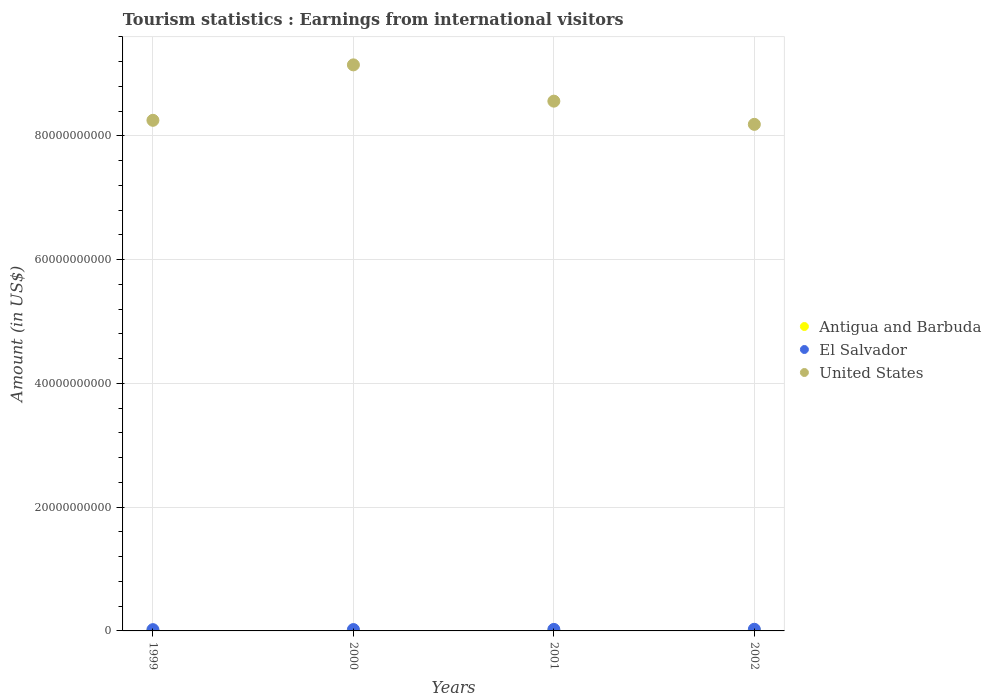What is the earnings from international visitors in Antigua and Barbuda in 2000?
Offer a terse response. 3.10e+07. Across all years, what is the maximum earnings from international visitors in Antigua and Barbuda?
Keep it short and to the point. 3.30e+07. Across all years, what is the minimum earnings from international visitors in United States?
Make the answer very short. 8.19e+1. In which year was the earnings from international visitors in El Salvador maximum?
Keep it short and to the point. 2002. What is the total earnings from international visitors in El Salvador in the graph?
Ensure brevity in your answer.  9.37e+08. What is the difference between the earnings from international visitors in El Salvador in 2000 and that in 2001?
Ensure brevity in your answer.  -2.80e+07. What is the difference between the earnings from international visitors in United States in 1999 and the earnings from international visitors in Antigua and Barbuda in 2001?
Your answer should be very brief. 8.25e+1. What is the average earnings from international visitors in Antigua and Barbuda per year?
Keep it short and to the point. 3.15e+07. In the year 1999, what is the difference between the earnings from international visitors in United States and earnings from international visitors in Antigua and Barbuda?
Your answer should be compact. 8.25e+1. What is the ratio of the earnings from international visitors in Antigua and Barbuda in 2000 to that in 2002?
Offer a very short reply. 0.94. Is the earnings from international visitors in Antigua and Barbuda in 2000 less than that in 2002?
Ensure brevity in your answer.  Yes. Is the difference between the earnings from international visitors in United States in 2000 and 2001 greater than the difference between the earnings from international visitors in Antigua and Barbuda in 2000 and 2001?
Make the answer very short. Yes. What is the difference between the highest and the second highest earnings from international visitors in El Salvador?
Your response must be concise. 1.90e+07. What is the difference between the highest and the lowest earnings from international visitors in El Salvador?
Ensure brevity in your answer.  6.10e+07. Is the sum of the earnings from international visitors in El Salvador in 1999 and 2001 greater than the maximum earnings from international visitors in United States across all years?
Make the answer very short. No. Is the earnings from international visitors in Antigua and Barbuda strictly greater than the earnings from international visitors in El Salvador over the years?
Your response must be concise. No. Are the values on the major ticks of Y-axis written in scientific E-notation?
Make the answer very short. No. Does the graph contain any zero values?
Your response must be concise. No. Does the graph contain grids?
Ensure brevity in your answer.  Yes. Where does the legend appear in the graph?
Provide a succinct answer. Center right. How many legend labels are there?
Offer a very short reply. 3. How are the legend labels stacked?
Provide a succinct answer. Vertical. What is the title of the graph?
Give a very brief answer. Tourism statistics : Earnings from international visitors. What is the label or title of the X-axis?
Make the answer very short. Years. What is the Amount (in US$) in Antigua and Barbuda in 1999?
Keep it short and to the point. 3.00e+07. What is the Amount (in US$) of El Salvador in 1999?
Provide a short and direct response. 2.05e+08. What is the Amount (in US$) of United States in 1999?
Provide a succinct answer. 8.25e+1. What is the Amount (in US$) in Antigua and Barbuda in 2000?
Your answer should be very brief. 3.10e+07. What is the Amount (in US$) in El Salvador in 2000?
Keep it short and to the point. 2.19e+08. What is the Amount (in US$) of United States in 2000?
Your response must be concise. 9.15e+1. What is the Amount (in US$) in Antigua and Barbuda in 2001?
Give a very brief answer. 3.20e+07. What is the Amount (in US$) of El Salvador in 2001?
Your answer should be very brief. 2.47e+08. What is the Amount (in US$) of United States in 2001?
Keep it short and to the point. 8.56e+1. What is the Amount (in US$) in Antigua and Barbuda in 2002?
Make the answer very short. 3.30e+07. What is the Amount (in US$) of El Salvador in 2002?
Your response must be concise. 2.66e+08. What is the Amount (in US$) in United States in 2002?
Provide a short and direct response. 8.19e+1. Across all years, what is the maximum Amount (in US$) of Antigua and Barbuda?
Your answer should be compact. 3.30e+07. Across all years, what is the maximum Amount (in US$) in El Salvador?
Provide a short and direct response. 2.66e+08. Across all years, what is the maximum Amount (in US$) in United States?
Your answer should be compact. 9.15e+1. Across all years, what is the minimum Amount (in US$) of Antigua and Barbuda?
Make the answer very short. 3.00e+07. Across all years, what is the minimum Amount (in US$) in El Salvador?
Your answer should be compact. 2.05e+08. Across all years, what is the minimum Amount (in US$) of United States?
Make the answer very short. 8.19e+1. What is the total Amount (in US$) of Antigua and Barbuda in the graph?
Your answer should be very brief. 1.26e+08. What is the total Amount (in US$) in El Salvador in the graph?
Keep it short and to the point. 9.37e+08. What is the total Amount (in US$) of United States in the graph?
Provide a short and direct response. 3.41e+11. What is the difference between the Amount (in US$) of El Salvador in 1999 and that in 2000?
Offer a very short reply. -1.40e+07. What is the difference between the Amount (in US$) of United States in 1999 and that in 2000?
Provide a short and direct response. -8.96e+09. What is the difference between the Amount (in US$) of Antigua and Barbuda in 1999 and that in 2001?
Offer a very short reply. -2.00e+06. What is the difference between the Amount (in US$) in El Salvador in 1999 and that in 2001?
Ensure brevity in your answer.  -4.20e+07. What is the difference between the Amount (in US$) in United States in 1999 and that in 2001?
Offer a very short reply. -3.10e+09. What is the difference between the Amount (in US$) in Antigua and Barbuda in 1999 and that in 2002?
Provide a succinct answer. -3.00e+06. What is the difference between the Amount (in US$) of El Salvador in 1999 and that in 2002?
Offer a terse response. -6.10e+07. What is the difference between the Amount (in US$) in United States in 1999 and that in 2002?
Offer a very short reply. 6.53e+08. What is the difference between the Amount (in US$) of El Salvador in 2000 and that in 2001?
Offer a very short reply. -2.80e+07. What is the difference between the Amount (in US$) of United States in 2000 and that in 2001?
Provide a short and direct response. 5.86e+09. What is the difference between the Amount (in US$) in Antigua and Barbuda in 2000 and that in 2002?
Your response must be concise. -2.00e+06. What is the difference between the Amount (in US$) of El Salvador in 2000 and that in 2002?
Your answer should be very brief. -4.70e+07. What is the difference between the Amount (in US$) in United States in 2000 and that in 2002?
Your answer should be very brief. 9.61e+09. What is the difference between the Amount (in US$) of El Salvador in 2001 and that in 2002?
Keep it short and to the point. -1.90e+07. What is the difference between the Amount (in US$) of United States in 2001 and that in 2002?
Give a very brief answer. 3.75e+09. What is the difference between the Amount (in US$) in Antigua and Barbuda in 1999 and the Amount (in US$) in El Salvador in 2000?
Ensure brevity in your answer.  -1.89e+08. What is the difference between the Amount (in US$) in Antigua and Barbuda in 1999 and the Amount (in US$) in United States in 2000?
Your response must be concise. -9.14e+1. What is the difference between the Amount (in US$) of El Salvador in 1999 and the Amount (in US$) of United States in 2000?
Offer a very short reply. -9.13e+1. What is the difference between the Amount (in US$) in Antigua and Barbuda in 1999 and the Amount (in US$) in El Salvador in 2001?
Your answer should be very brief. -2.17e+08. What is the difference between the Amount (in US$) in Antigua and Barbuda in 1999 and the Amount (in US$) in United States in 2001?
Your response must be concise. -8.56e+1. What is the difference between the Amount (in US$) of El Salvador in 1999 and the Amount (in US$) of United States in 2001?
Offer a very short reply. -8.54e+1. What is the difference between the Amount (in US$) in Antigua and Barbuda in 1999 and the Amount (in US$) in El Salvador in 2002?
Ensure brevity in your answer.  -2.36e+08. What is the difference between the Amount (in US$) of Antigua and Barbuda in 1999 and the Amount (in US$) of United States in 2002?
Provide a short and direct response. -8.18e+1. What is the difference between the Amount (in US$) in El Salvador in 1999 and the Amount (in US$) in United States in 2002?
Make the answer very short. -8.17e+1. What is the difference between the Amount (in US$) of Antigua and Barbuda in 2000 and the Amount (in US$) of El Salvador in 2001?
Give a very brief answer. -2.16e+08. What is the difference between the Amount (in US$) of Antigua and Barbuda in 2000 and the Amount (in US$) of United States in 2001?
Provide a succinct answer. -8.56e+1. What is the difference between the Amount (in US$) of El Salvador in 2000 and the Amount (in US$) of United States in 2001?
Your answer should be very brief. -8.54e+1. What is the difference between the Amount (in US$) of Antigua and Barbuda in 2000 and the Amount (in US$) of El Salvador in 2002?
Give a very brief answer. -2.35e+08. What is the difference between the Amount (in US$) of Antigua and Barbuda in 2000 and the Amount (in US$) of United States in 2002?
Give a very brief answer. -8.18e+1. What is the difference between the Amount (in US$) in El Salvador in 2000 and the Amount (in US$) in United States in 2002?
Keep it short and to the point. -8.16e+1. What is the difference between the Amount (in US$) in Antigua and Barbuda in 2001 and the Amount (in US$) in El Salvador in 2002?
Make the answer very short. -2.34e+08. What is the difference between the Amount (in US$) of Antigua and Barbuda in 2001 and the Amount (in US$) of United States in 2002?
Keep it short and to the point. -8.18e+1. What is the difference between the Amount (in US$) in El Salvador in 2001 and the Amount (in US$) in United States in 2002?
Offer a terse response. -8.16e+1. What is the average Amount (in US$) in Antigua and Barbuda per year?
Provide a short and direct response. 3.15e+07. What is the average Amount (in US$) of El Salvador per year?
Keep it short and to the point. 2.34e+08. What is the average Amount (in US$) of United States per year?
Offer a terse response. 8.54e+1. In the year 1999, what is the difference between the Amount (in US$) in Antigua and Barbuda and Amount (in US$) in El Salvador?
Provide a short and direct response. -1.75e+08. In the year 1999, what is the difference between the Amount (in US$) of Antigua and Barbuda and Amount (in US$) of United States?
Ensure brevity in your answer.  -8.25e+1. In the year 1999, what is the difference between the Amount (in US$) of El Salvador and Amount (in US$) of United States?
Offer a terse response. -8.23e+1. In the year 2000, what is the difference between the Amount (in US$) of Antigua and Barbuda and Amount (in US$) of El Salvador?
Ensure brevity in your answer.  -1.88e+08. In the year 2000, what is the difference between the Amount (in US$) in Antigua and Barbuda and Amount (in US$) in United States?
Provide a short and direct response. -9.14e+1. In the year 2000, what is the difference between the Amount (in US$) in El Salvador and Amount (in US$) in United States?
Offer a terse response. -9.13e+1. In the year 2001, what is the difference between the Amount (in US$) of Antigua and Barbuda and Amount (in US$) of El Salvador?
Keep it short and to the point. -2.15e+08. In the year 2001, what is the difference between the Amount (in US$) in Antigua and Barbuda and Amount (in US$) in United States?
Provide a succinct answer. -8.56e+1. In the year 2001, what is the difference between the Amount (in US$) in El Salvador and Amount (in US$) in United States?
Ensure brevity in your answer.  -8.54e+1. In the year 2002, what is the difference between the Amount (in US$) in Antigua and Barbuda and Amount (in US$) in El Salvador?
Offer a very short reply. -2.33e+08. In the year 2002, what is the difference between the Amount (in US$) in Antigua and Barbuda and Amount (in US$) in United States?
Your answer should be very brief. -8.18e+1. In the year 2002, what is the difference between the Amount (in US$) in El Salvador and Amount (in US$) in United States?
Give a very brief answer. -8.16e+1. What is the ratio of the Amount (in US$) in Antigua and Barbuda in 1999 to that in 2000?
Your answer should be compact. 0.97. What is the ratio of the Amount (in US$) in El Salvador in 1999 to that in 2000?
Your answer should be compact. 0.94. What is the ratio of the Amount (in US$) of United States in 1999 to that in 2000?
Provide a short and direct response. 0.9. What is the ratio of the Amount (in US$) in Antigua and Barbuda in 1999 to that in 2001?
Your response must be concise. 0.94. What is the ratio of the Amount (in US$) in El Salvador in 1999 to that in 2001?
Ensure brevity in your answer.  0.83. What is the ratio of the Amount (in US$) of United States in 1999 to that in 2001?
Your answer should be compact. 0.96. What is the ratio of the Amount (in US$) of Antigua and Barbuda in 1999 to that in 2002?
Provide a succinct answer. 0.91. What is the ratio of the Amount (in US$) in El Salvador in 1999 to that in 2002?
Offer a very short reply. 0.77. What is the ratio of the Amount (in US$) in Antigua and Barbuda in 2000 to that in 2001?
Offer a very short reply. 0.97. What is the ratio of the Amount (in US$) of El Salvador in 2000 to that in 2001?
Your response must be concise. 0.89. What is the ratio of the Amount (in US$) of United States in 2000 to that in 2001?
Offer a terse response. 1.07. What is the ratio of the Amount (in US$) of Antigua and Barbuda in 2000 to that in 2002?
Provide a short and direct response. 0.94. What is the ratio of the Amount (in US$) of El Salvador in 2000 to that in 2002?
Your response must be concise. 0.82. What is the ratio of the Amount (in US$) in United States in 2000 to that in 2002?
Offer a terse response. 1.12. What is the ratio of the Amount (in US$) of Antigua and Barbuda in 2001 to that in 2002?
Give a very brief answer. 0.97. What is the ratio of the Amount (in US$) of El Salvador in 2001 to that in 2002?
Offer a very short reply. 0.93. What is the ratio of the Amount (in US$) of United States in 2001 to that in 2002?
Make the answer very short. 1.05. What is the difference between the highest and the second highest Amount (in US$) in Antigua and Barbuda?
Provide a succinct answer. 1.00e+06. What is the difference between the highest and the second highest Amount (in US$) of El Salvador?
Provide a short and direct response. 1.90e+07. What is the difference between the highest and the second highest Amount (in US$) in United States?
Offer a terse response. 5.86e+09. What is the difference between the highest and the lowest Amount (in US$) in El Salvador?
Make the answer very short. 6.10e+07. What is the difference between the highest and the lowest Amount (in US$) in United States?
Your response must be concise. 9.61e+09. 